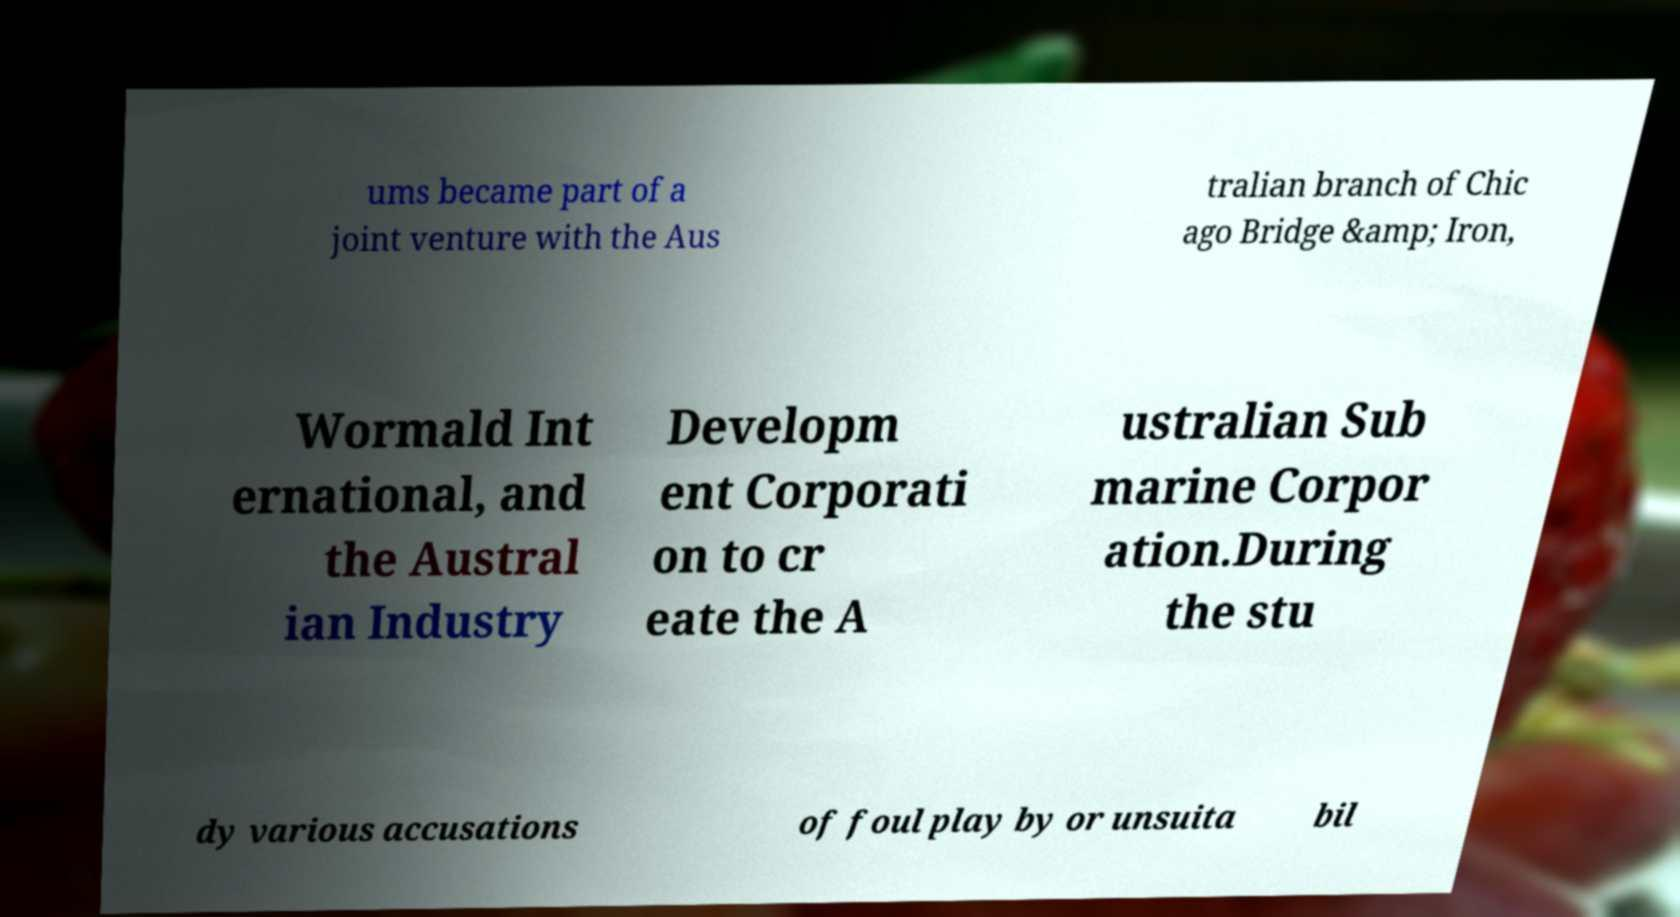Please read and relay the text visible in this image. What does it say? ums became part of a joint venture with the Aus tralian branch of Chic ago Bridge &amp; Iron, Wormald Int ernational, and the Austral ian Industry Developm ent Corporati on to cr eate the A ustralian Sub marine Corpor ation.During the stu dy various accusations of foul play by or unsuita bil 